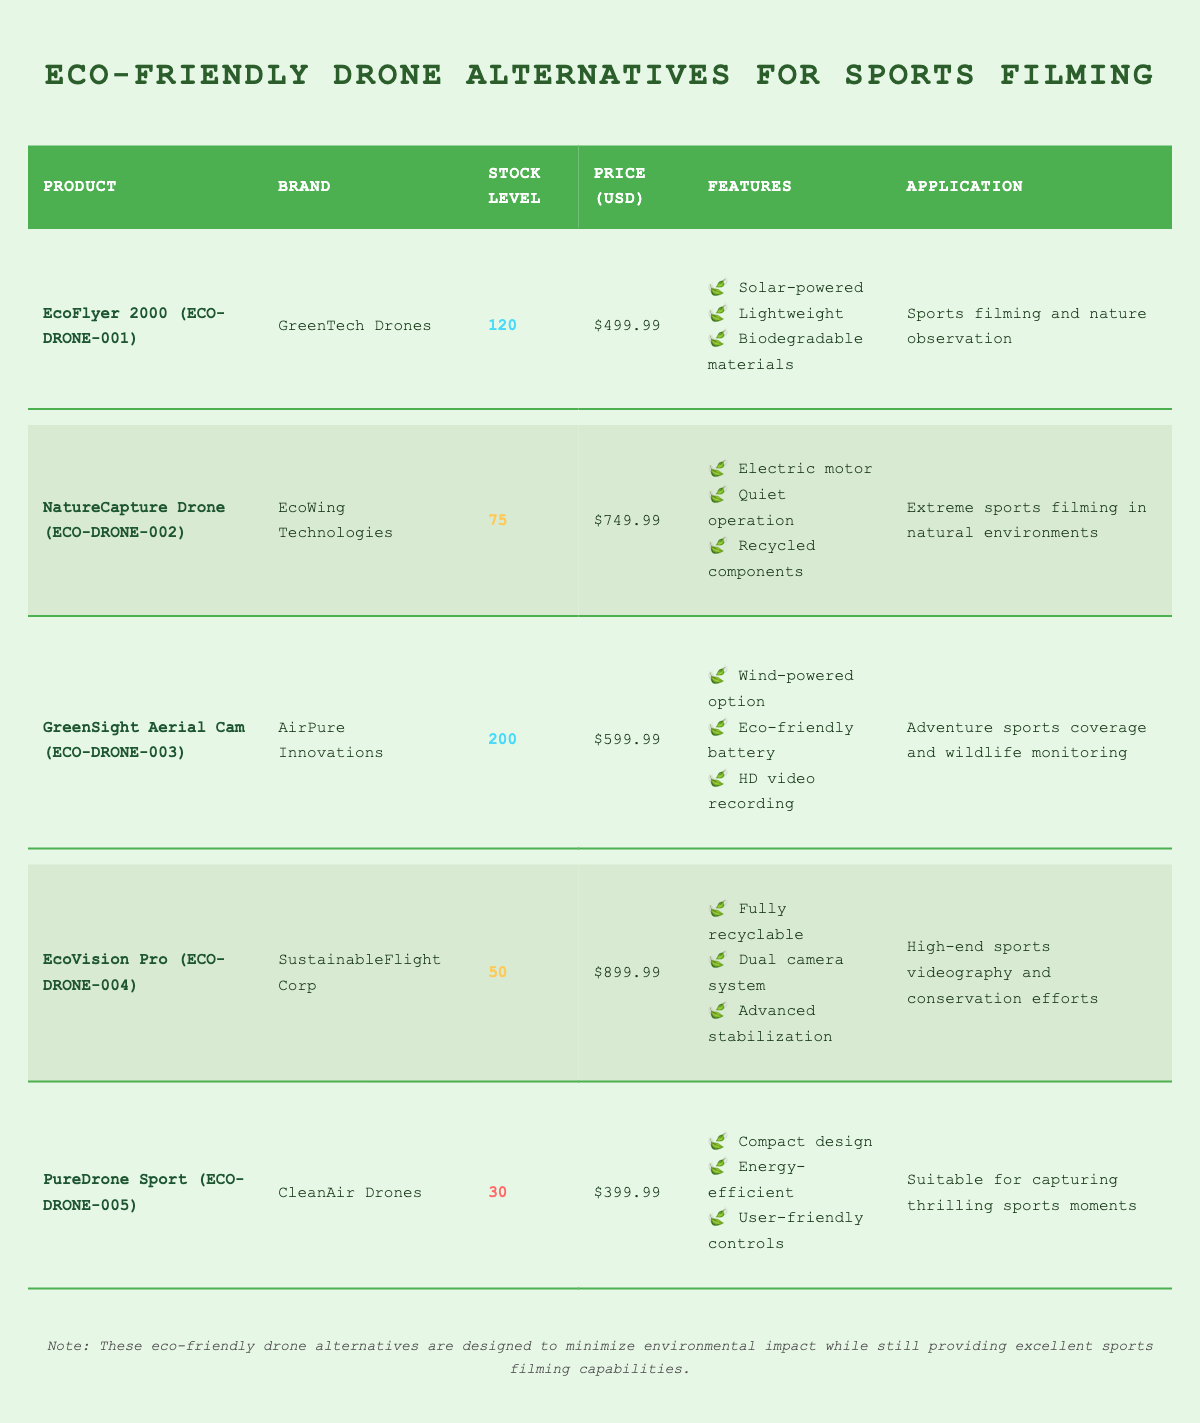What is the stock level of the NatureCapture Drone? The stock level can be found in the table under the "Stock Level" column corresponding to the "NatureCapture Drone". The value listed there is 75.
Answer: 75 Which drone has the lowest stock level? To find the drone with the lowest stock level, we can look at the "Stock Level" column and compare the values. The "PureDrone Sport" has a stock level of 30, which is the lowest among all listed drones.
Answer: PureDrone Sport What is the total stock level of all drones listed? To find the total stock level, we sum the stock levels of all products: 120 (EcoFlyer 2000) + 75 (NatureCapture Drone) + 200 (GreenSight Aerial Cam) + 50 (EcoVision Pro) + 30 (PureDrone Sport) = 475.
Answer: 475 Is the EcoFlyer 2000 priced below 500 USD? The price of the EcoFlyer 2000 is listed as 499.99 USD, which is indeed below 500 USD.
Answer: Yes What is the average price of the eco-friendly drones in the inventory? To calculate the average price, we first sum the prices of all five drones: 499.99 + 749.99 + 599.99 + 899.99 + 399.99 = 3,149.95. Then we divide by the number of drones, which is 5. Thus, the average price is 3,149.95 / 5 = 629.99.
Answer: 629.99 Which brand has the most stock available? By comparing the stock levels, the "GreenSight Aerial Cam" has the highest stock level at 200. Hence, the brand with the most stock available is "AirPure Innovations", associated with the GreenSight Aerial Cam.
Answer: AirPure Innovations Are all drones intended for sports filming applications? Looking at the "Application" column, we note that all drones are indeed stated to support sports filming or related activities such as nature observation and wildlife monitoring.
Answer: Yes What features are unique to the EcoVision Pro? To identify unique features for the EcoVision Pro, we look at its "Features" list and find "Fully recyclable", "Dual camera system", and "Advanced stabilization", examining other drones for overlaps confirms these are specific to the EcoVision Pro or noted as distinct.
Answer: Fully recyclable, Dual camera system, Advanced stabilization 